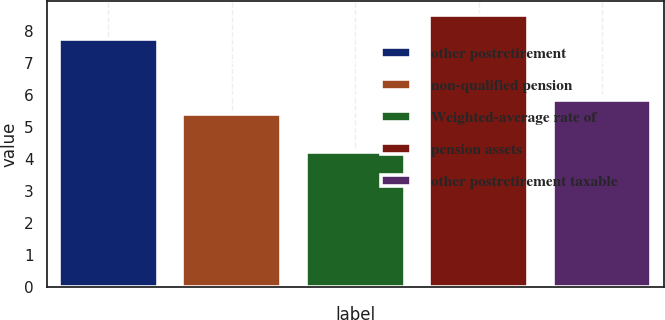Convert chart. <chart><loc_0><loc_0><loc_500><loc_500><bar_chart><fcel>other postretirement<fcel>non-qualified pension<fcel>Weighted-average rate of<fcel>pension assets<fcel>other postretirement taxable<nl><fcel>7.75<fcel>5.4<fcel>4.23<fcel>8.5<fcel>5.83<nl></chart> 